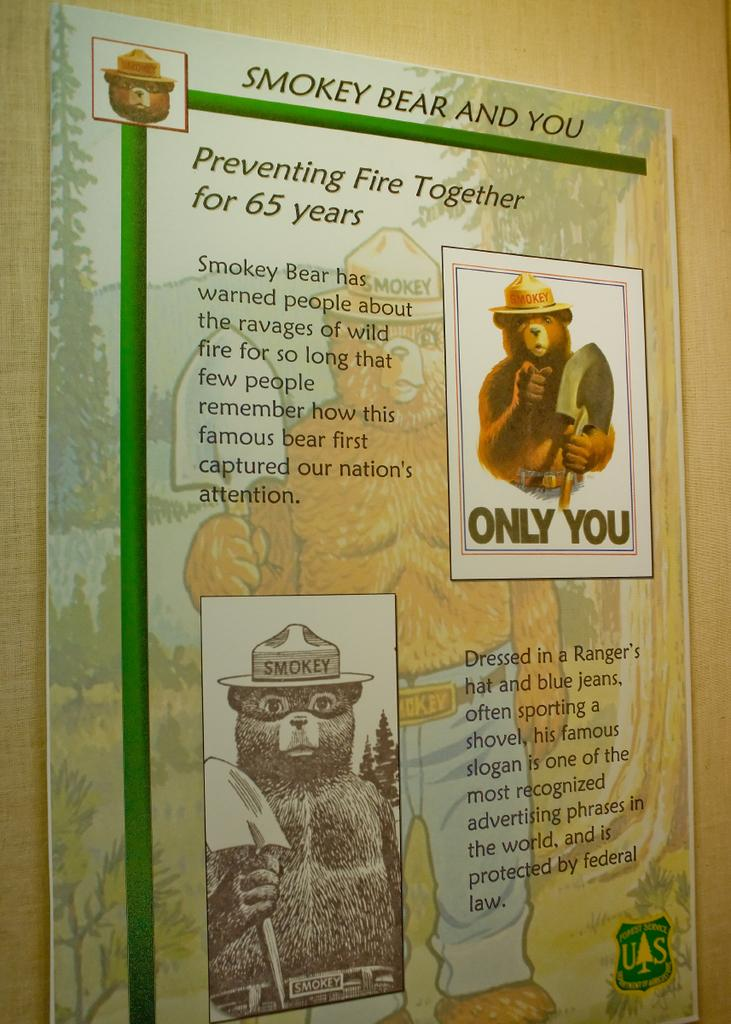<image>
Present a compact description of the photo's key features. A poster with Smokey Bear on it says Preventing Fire Together for 65 years. 